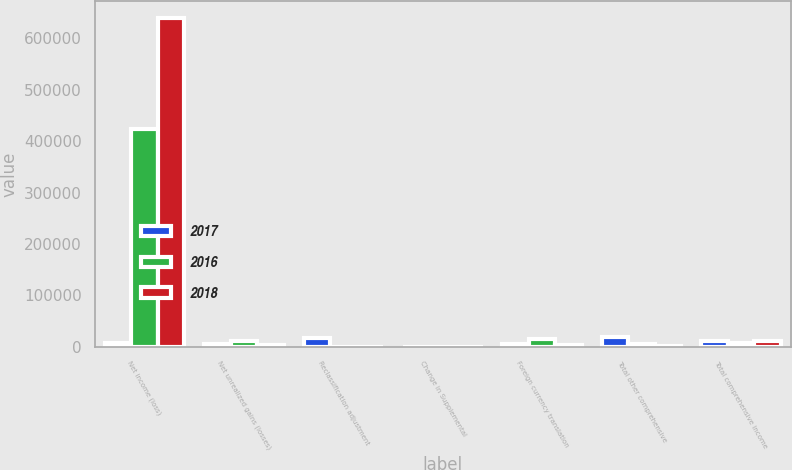Convert chart to OTSL. <chart><loc_0><loc_0><loc_500><loc_500><stacked_bar_chart><ecel><fcel>Net income (loss)<fcel>Net unrealized gains (losses)<fcel>Reclassification adjustment<fcel>Change in Supplemental<fcel>Foreign currency translation<fcel>Total other comprehensive<fcel>Total comprehensive income<nl><fcel>2017<fcel>7245<fcel>6025<fcel>18088<fcel>561<fcel>5358<fcel>19316<fcel>12381<nl><fcel>2016<fcel>422634<fcel>11107<fcel>799<fcel>64<fcel>15862<fcel>5618<fcel>8465<nl><fcel>2018<fcel>639926<fcel>3233<fcel>707<fcel>220<fcel>3332<fcel>828<fcel>12179<nl></chart> 